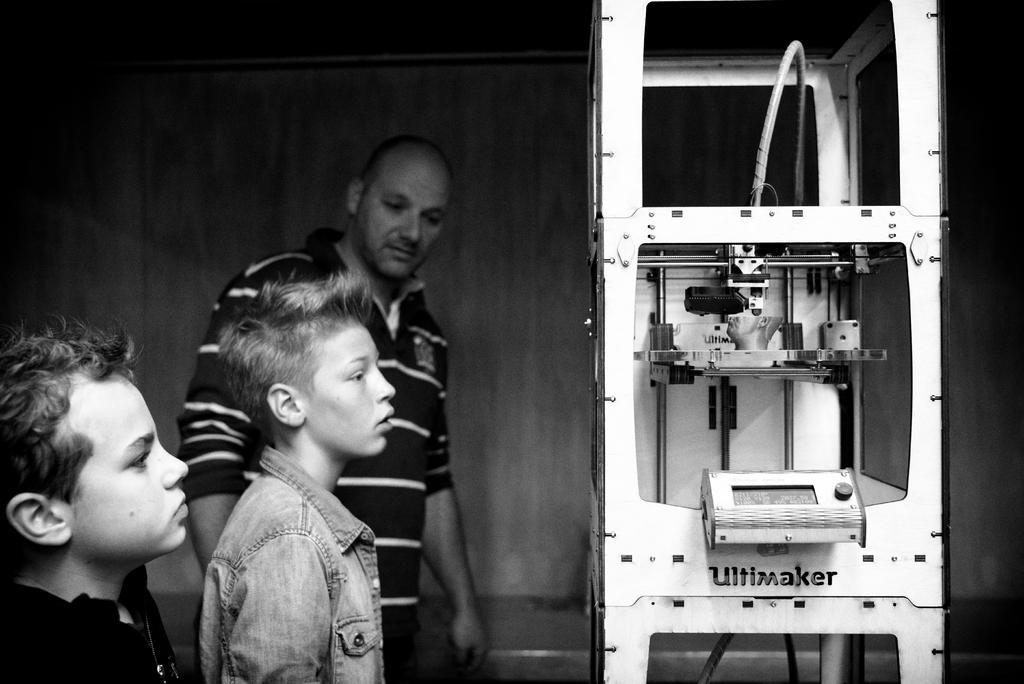Can you describe this image briefly? In this image we can see three people standing. On the right we can see a machine. In the background there is a wall. 